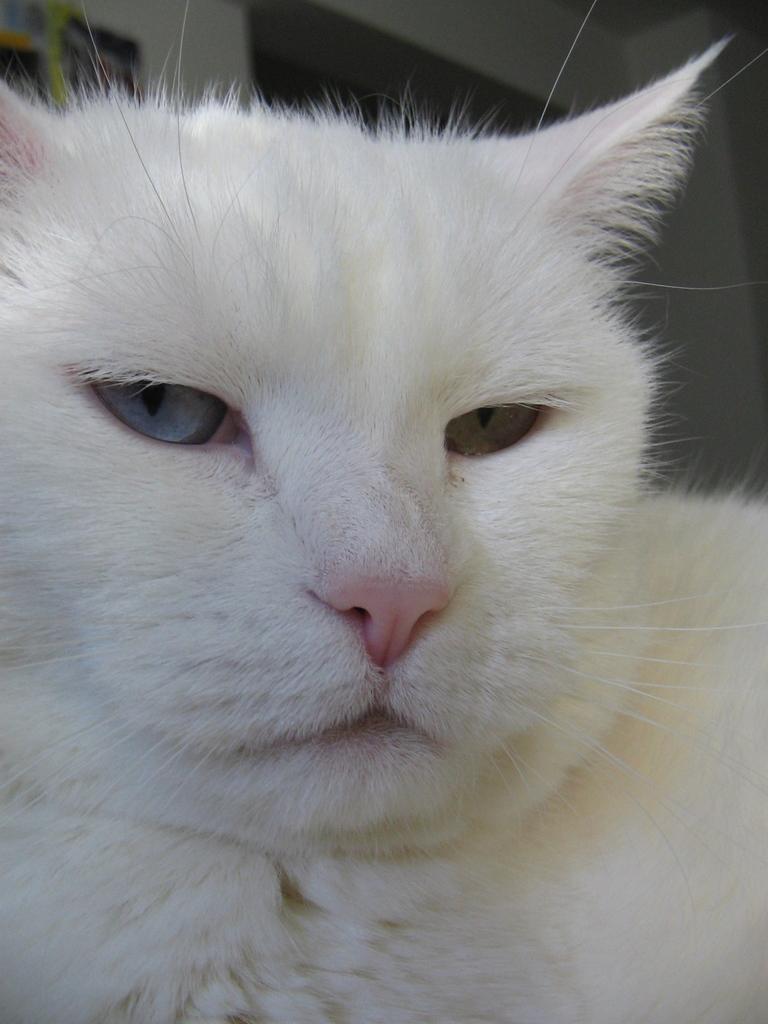Can you describe this image briefly? In this picture there is a white cat. In the back we can see the door. On the top left corner we can see the photo frames on the wall. 